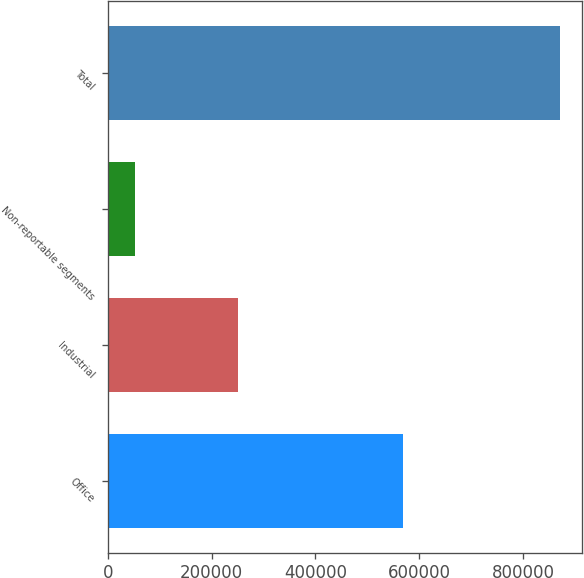<chart> <loc_0><loc_0><loc_500><loc_500><bar_chart><fcel>Office<fcel>Industrial<fcel>Non-reportable segments<fcel>Total<nl><fcel>568405<fcel>250078<fcel>51889<fcel>870372<nl></chart> 